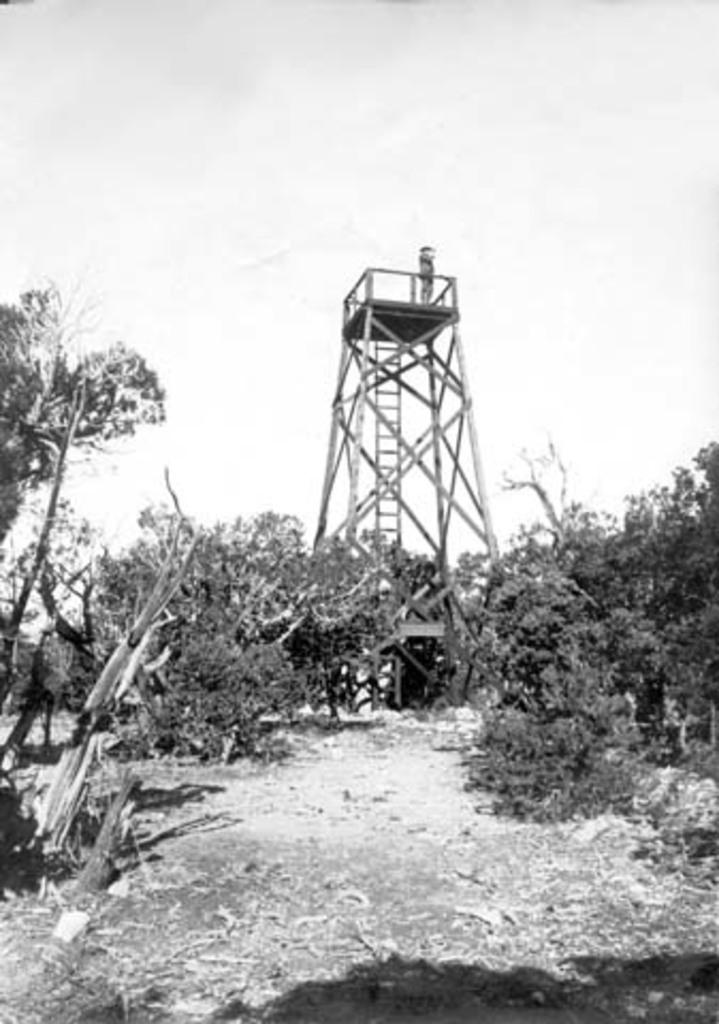What is the color scheme of the image? The image is black and white. What type of natural elements can be seen in the image? There are trees in the image. Where are the trees located in relation to the ground? The trees are on the ground in the image. What man-made structure is present in the image? There is a tower bridge in the image. Can you see any boats floating on the water in the image? There is no water or boats present in the image; it features a black and white scene with trees and a tower bridge. 